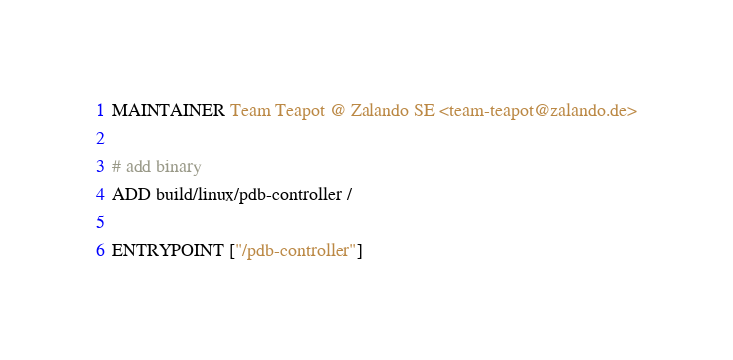Convert code to text. <code><loc_0><loc_0><loc_500><loc_500><_Dockerfile_>MAINTAINER Team Teapot @ Zalando SE <team-teapot@zalando.de>

# add binary
ADD build/linux/pdb-controller /

ENTRYPOINT ["/pdb-controller"]
</code> 